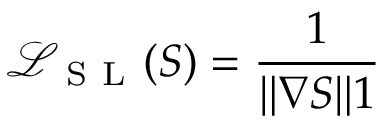Convert formula to latex. <formula><loc_0><loc_0><loc_500><loc_500>\mathcal { L } _ { S L } ( S ) = \frac { 1 } { \| \nabla S \| 1 }</formula> 